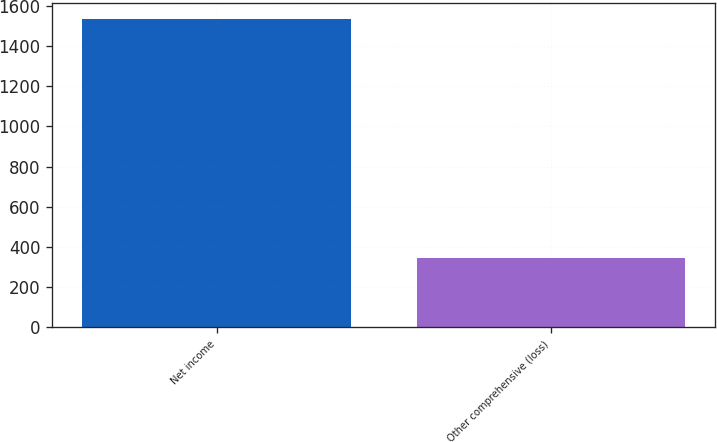Convert chart to OTSL. <chart><loc_0><loc_0><loc_500><loc_500><bar_chart><fcel>Net income<fcel>Other comprehensive (loss)<nl><fcel>1535<fcel>344<nl></chart> 